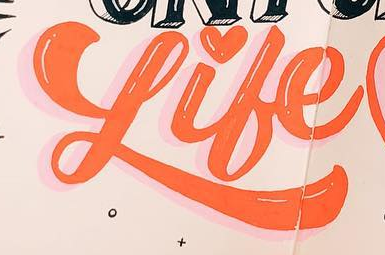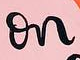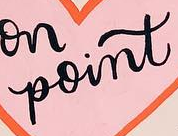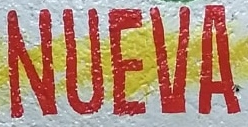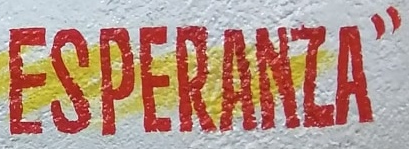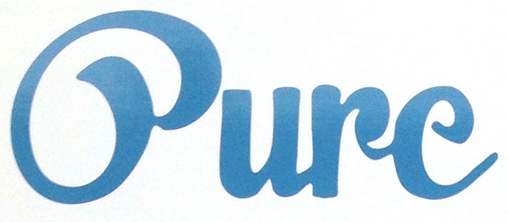What words are shown in these images in order, separated by a semicolon? Like; on; point; NUEVA; ESPERANZA"; Oure 